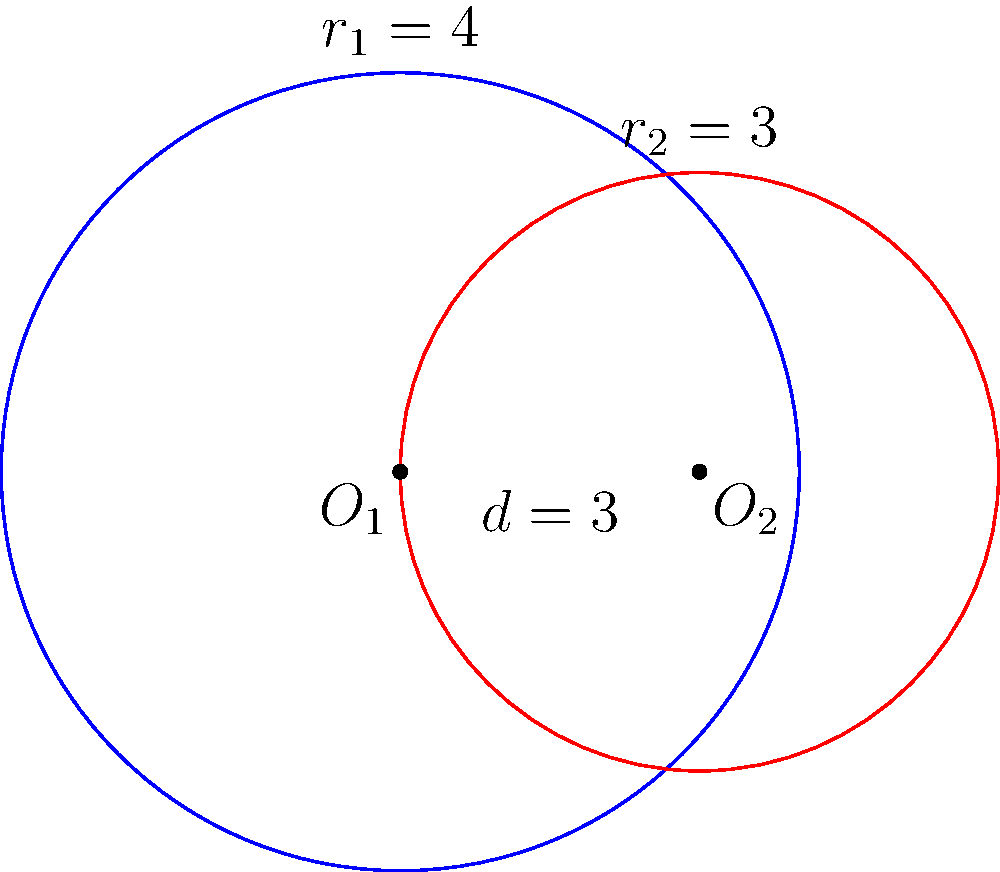In Baryshivka, two ancient circular settlements were discovered, represented by the blue and red circles in the diagram. The blue circle has a radius of 4 km, while the red circle has a radius of 3 km. The centers of these settlements are 3 km apart. Calculate the area of the overlapping region between these two settlements, rounding your answer to two decimal places. To find the area of the overlapping region between two intersecting circles, we can use the following steps:

1) First, we need to calculate the angle θ (in radians) at the center of each circle that subtends the overlapping region. We can use the cosine law:

   For the blue circle: $\cos(\theta_1/2) = \frac{d^2 + r_1^2 - r_2^2}{2dr_1}$
   For the red circle: $\cos(\theta_2/2) = \frac{d^2 + r_2^2 - r_1^2}{2dr_2}$

   Where $d = 3$, $r_1 = 4$, and $r_2 = 3$

2) Calculate $\theta_1$:
   $\cos(\theta_1/2) = \frac{3^2 + 4^2 - 3^2}{2 * 3 * 4} = \frac{16}{24} = \frac{2}{3}$
   $\theta_1 = 2 * \arccos(\frac{2}{3}) \approx 1.8318$ radians

3) Calculate $\theta_2$:
   $\cos(\theta_2/2) = \frac{3^2 + 3^2 - 4^2}{2 * 3 * 3} = \frac{-1}{6}$
   $\theta_2 = 2 * \arccos(-\frac{1}{6}) \approx 2.7271$ radians

4) The area of the overlapping region is the sum of the areas of the two circular sectors minus the area of the rhombus formed by the intersecting chords:

   Area = $\frac{1}{2}r_1^2\theta_1 + \frac{1}{2}r_2^2\theta_2 - r_1^2\sin(\frac{\theta_1}{2}) - r_2^2\sin(\frac{\theta_2}{2})$

5) Substituting the values:
   Area = $\frac{1}{2}*4^2*1.8318 + \frac{1}{2}*3^2*2.7271 - 4^2\sin(\frac{1.8318}{2}) - 3^2\sin(\frac{2.7271}{2})$
        $\approx 14.6544 + 12.2719 - 13.8564 - 8.9699$
        $\approx 4.1000$ sq km

6) Rounding to two decimal places: 4.10 sq km
Answer: 4.10 sq km 